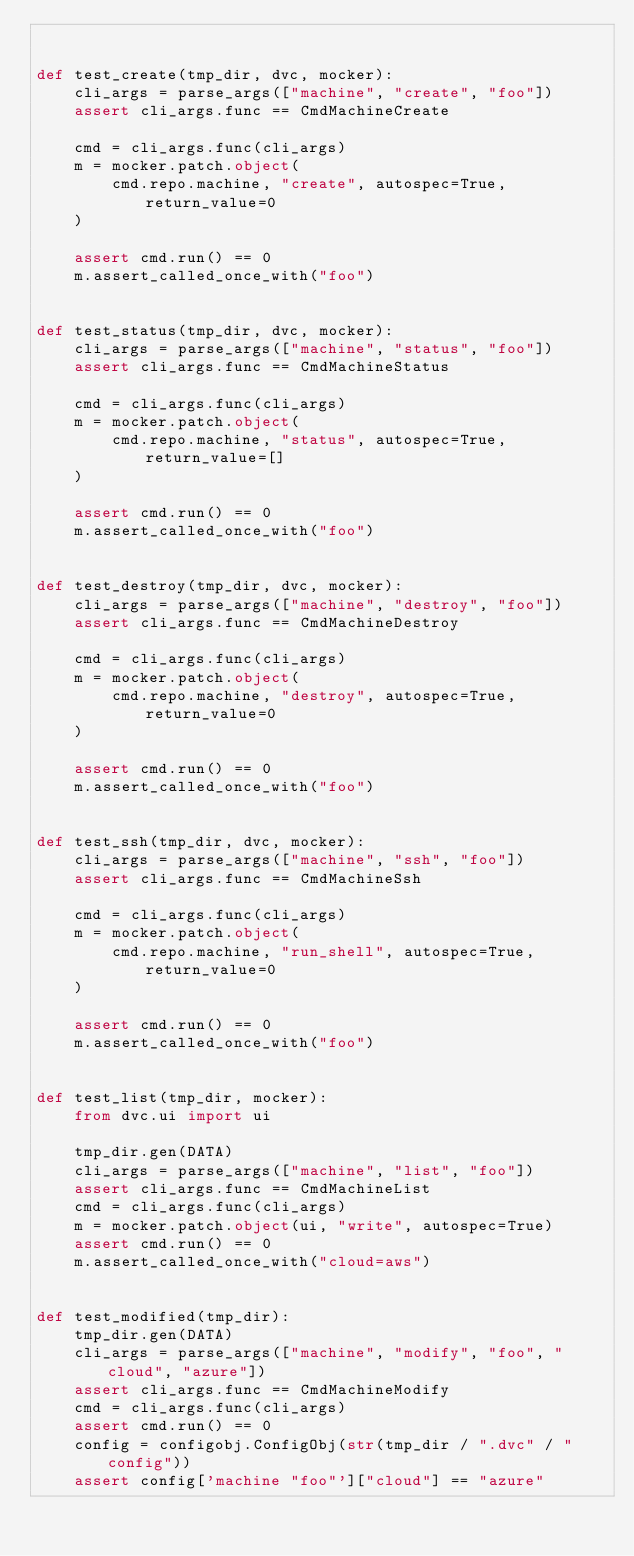Convert code to text. <code><loc_0><loc_0><loc_500><loc_500><_Python_>

def test_create(tmp_dir, dvc, mocker):
    cli_args = parse_args(["machine", "create", "foo"])
    assert cli_args.func == CmdMachineCreate

    cmd = cli_args.func(cli_args)
    m = mocker.patch.object(
        cmd.repo.machine, "create", autospec=True, return_value=0
    )

    assert cmd.run() == 0
    m.assert_called_once_with("foo")


def test_status(tmp_dir, dvc, mocker):
    cli_args = parse_args(["machine", "status", "foo"])
    assert cli_args.func == CmdMachineStatus

    cmd = cli_args.func(cli_args)
    m = mocker.patch.object(
        cmd.repo.machine, "status", autospec=True, return_value=[]
    )

    assert cmd.run() == 0
    m.assert_called_once_with("foo")


def test_destroy(tmp_dir, dvc, mocker):
    cli_args = parse_args(["machine", "destroy", "foo"])
    assert cli_args.func == CmdMachineDestroy

    cmd = cli_args.func(cli_args)
    m = mocker.patch.object(
        cmd.repo.machine, "destroy", autospec=True, return_value=0
    )

    assert cmd.run() == 0
    m.assert_called_once_with("foo")


def test_ssh(tmp_dir, dvc, mocker):
    cli_args = parse_args(["machine", "ssh", "foo"])
    assert cli_args.func == CmdMachineSsh

    cmd = cli_args.func(cli_args)
    m = mocker.patch.object(
        cmd.repo.machine, "run_shell", autospec=True, return_value=0
    )

    assert cmd.run() == 0
    m.assert_called_once_with("foo")


def test_list(tmp_dir, mocker):
    from dvc.ui import ui

    tmp_dir.gen(DATA)
    cli_args = parse_args(["machine", "list", "foo"])
    assert cli_args.func == CmdMachineList
    cmd = cli_args.func(cli_args)
    m = mocker.patch.object(ui, "write", autospec=True)
    assert cmd.run() == 0
    m.assert_called_once_with("cloud=aws")


def test_modified(tmp_dir):
    tmp_dir.gen(DATA)
    cli_args = parse_args(["machine", "modify", "foo", "cloud", "azure"])
    assert cli_args.func == CmdMachineModify
    cmd = cli_args.func(cli_args)
    assert cmd.run() == 0
    config = configobj.ConfigObj(str(tmp_dir / ".dvc" / "config"))
    assert config['machine "foo"']["cloud"] == "azure"
</code> 